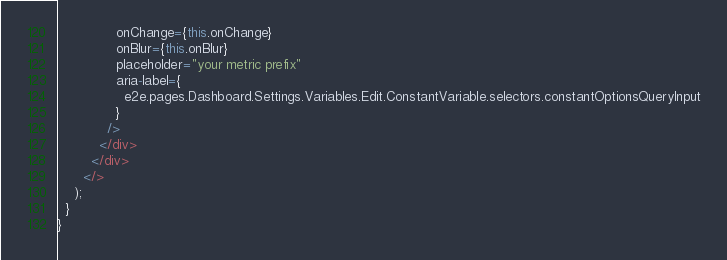Convert code to text. <code><loc_0><loc_0><loc_500><loc_500><_TypeScript_>              onChange={this.onChange}
              onBlur={this.onBlur}
              placeholder="your metric prefix"
              aria-label={
                e2e.pages.Dashboard.Settings.Variables.Edit.ConstantVariable.selectors.constantOptionsQueryInput
              }
            />
          </div>
        </div>
      </>
    );
  }
}
</code> 